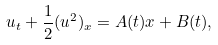<formula> <loc_0><loc_0><loc_500><loc_500>u _ { t } + \frac { 1 } { 2 } ( u ^ { 2 } ) _ { x } = A ( t ) x + B ( t ) ,</formula> 